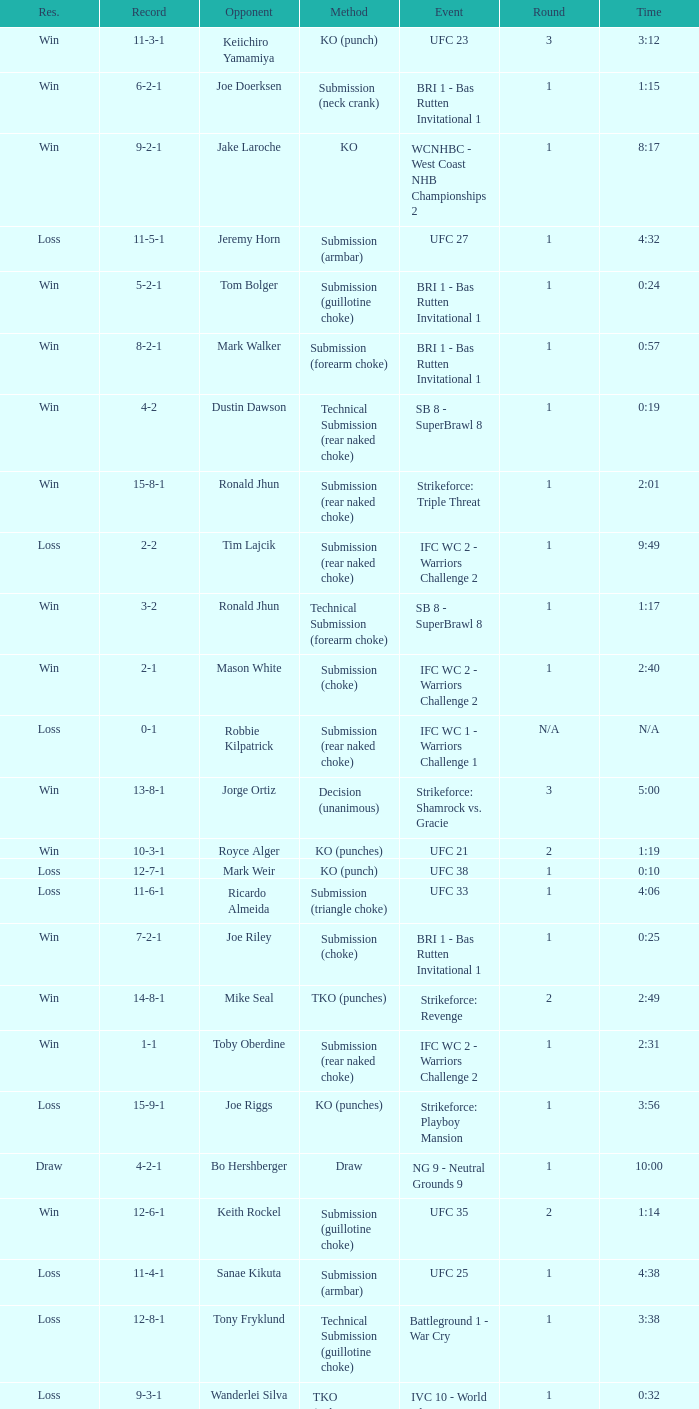What was the record when the method of resolution was KO? 9-2-1. 